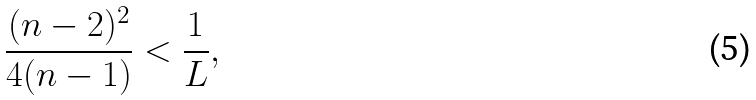<formula> <loc_0><loc_0><loc_500><loc_500>\frac { ( n - 2 ) ^ { 2 } } { 4 ( n - 1 ) } < \frac { 1 } { L } ,</formula> 